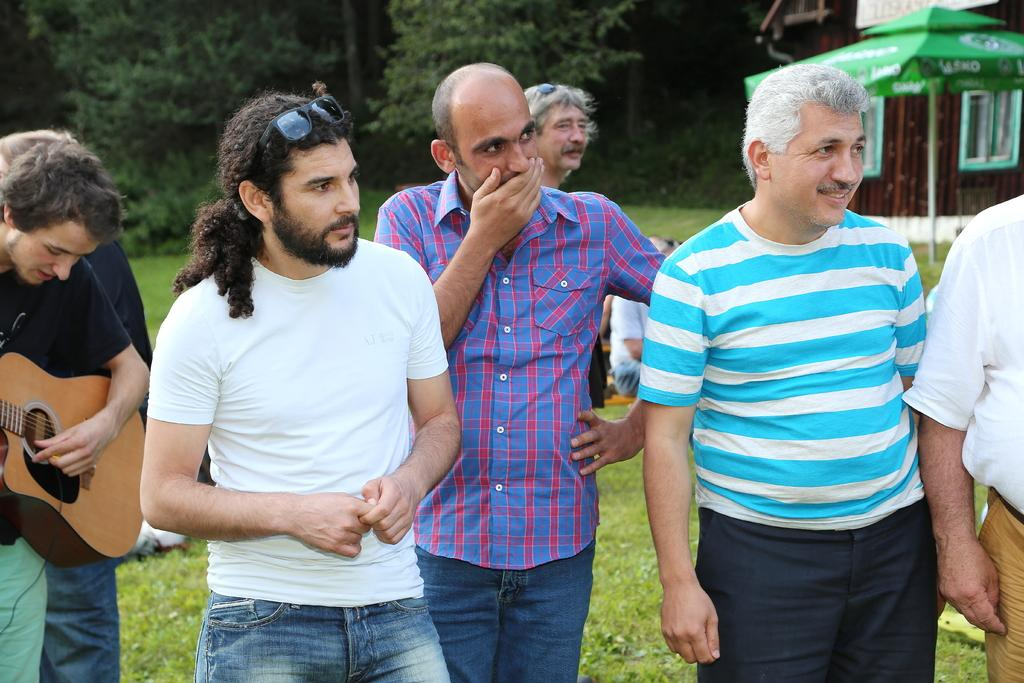How many people are standing in the image? There are four persons standing horizontally in the image. Can you describe the background of the image? In the background, there is another person, a tree, a house, and grass. What is the position of the person in the image? There is a person sitting in the image. What structure can be seen in the background? There is a house in the background. What type of vegetation is visible in the background? There is grass in the background. What type of toothpaste is being used by the person sitting in the image? There is no toothpaste present in the image, as it features people standing and sitting, as well as a background with a house, tree, and grass. 